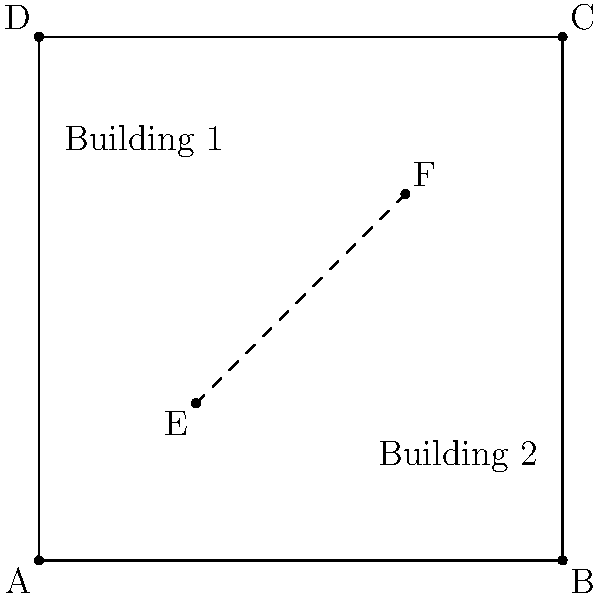Given the property layout shown in the diagram, where two buildings are located at opposite corners, determine the optimal path for laying utility lines to minimize costs. The dashed line represents the shortest possible route. Calculate the percentage increase in length if the utility lines must follow the property boundaries instead of the direct path. Round your answer to the nearest whole percentage. To solve this problem, we'll follow these steps:

1. Calculate the length of the direct path (dashed line):
   The direct path forms the hypotenuse of a right triangle.
   Using the Pythagorean theorem: $\sqrt{(70-30)^2 + (70-30)^2} = \sqrt{40^2 + 40^2} = \sqrt{3200} \approx 56.57$ units

2. Calculate the length of the path along the property boundaries:
   This path consists of two segments: E to (100,30) and (100,30) to F
   Length = $(100-30) + (70-30) = 70 + 40 = 110$ units

3. Calculate the percentage increase:
   Percentage increase = $\frac{\text{New Length} - \text{Original Length}}{\text{Original Length}} \times 100\%$
   $= \frac{110 - 56.57}{56.57} \times 100\% \approx 94.45\%$

4. Round to the nearest whole percentage:
   94.45% rounds to 94%
Answer: 94% 